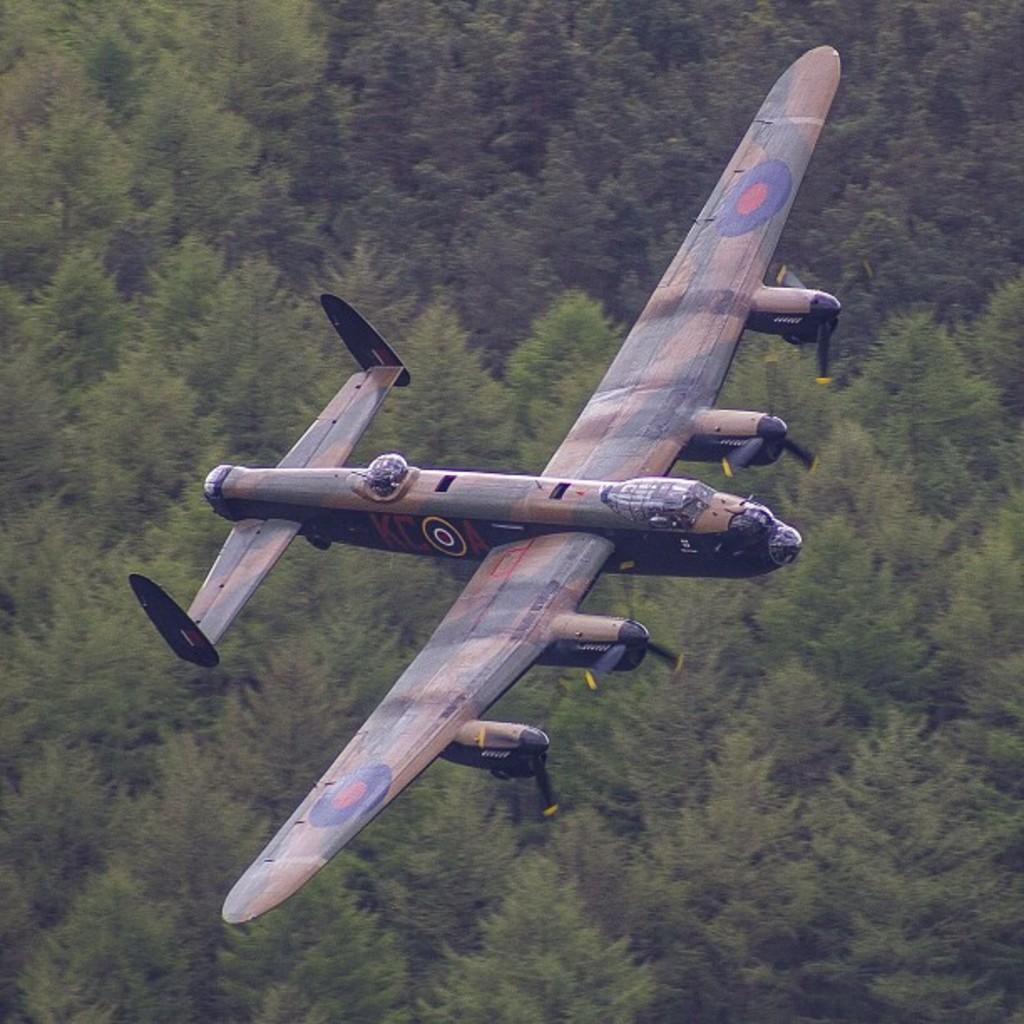What is flying in the air in the image? There is an aircraft flying in the air in the image. What can be observed about the trees in the image? The trees have green color leaves. How fast is the card running in the image? There is no card or running depicted in the image; it features an aircraft flying in the air and trees with green leaves. 